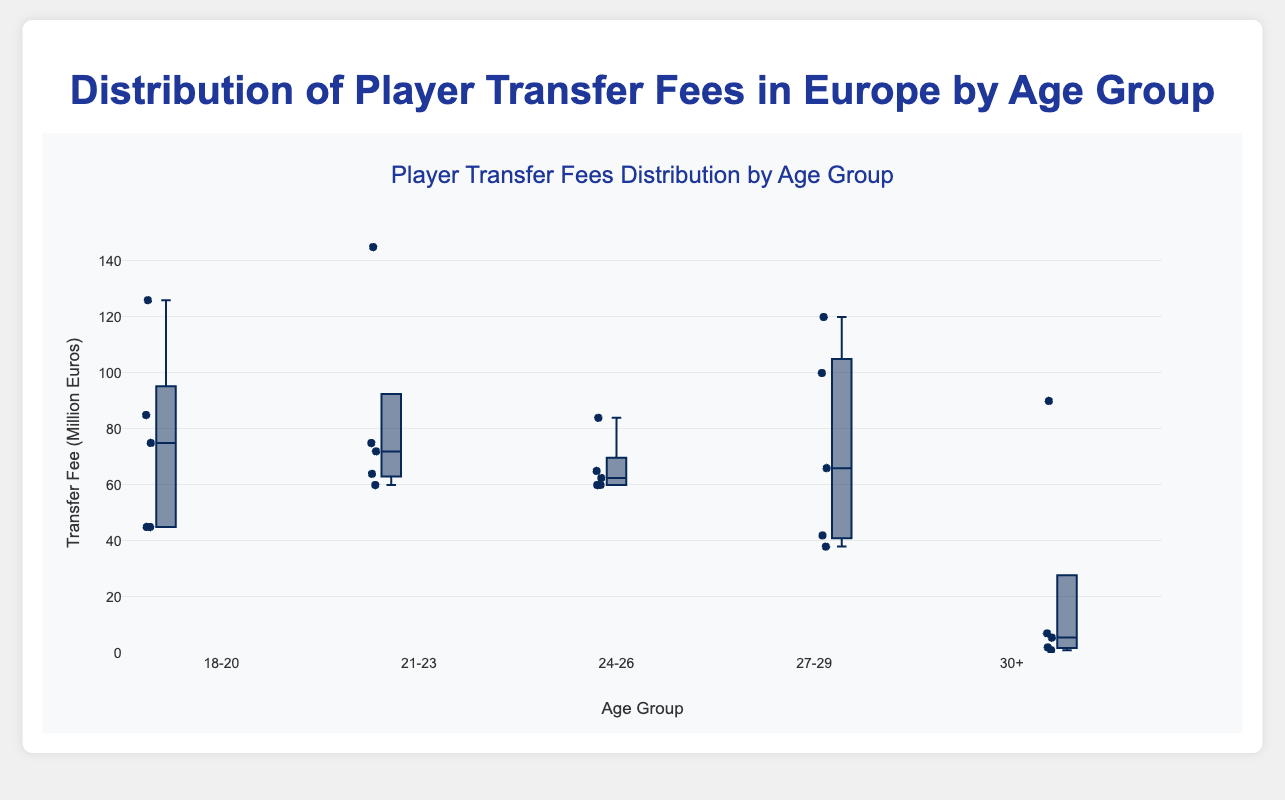Which age group has the highest median transfer fee? The median is typically visualized by the line inside the box of each box plot. By inspecting the line inside the box, we see that the 21-23 age group has the highest median transfer fee.
Answer: 21-23 What is the range of transfer fees for the 27-29 age group? The range is the difference between the maximum and minimum values. For the 27-29 age group, this range is depicted from the topmost to the bottommost point of the whiskers.
Answer: 120 - 38 = 82 million euros Which age group has the widest spread of transfer fees? The spread is indicated by the length of the box and whiskers. By comparing the lengths, the 30+ age group has the widest spread of transfer fees.
Answer: 30+ What is the interquartile range (IQR) for the 18-20 age group? The IQR is found by subtracting the value at the first quartile (Q1) from the value at the third quartile (Q3). For the 18-20 age group, Q1 is around 45 million euros and Q3 is around 85 million euros. IQR = Q3 - Q1.
Answer: 85 - 45 = 40 million euros Which player has the highest transfer fee in the 21-23 age group? Inspect the highest data point within the 21-23 age group box plot. The highest point is labeled with the player Kylian Mbappé, who has a fee of 145 million euros.
Answer: Kylian Mbappé How do the transfer fees for players aged 18-20 compare to those aged 30+? We need to compare both the median values and the spread of the data. From the box plots, the 18-20 age group has a higher median transfer fee and a more compact spread compared to the wider and lower spread of the 30+ age group.
Answer: 18-20 has higher median; 30+ has wider spread What is the approximate median transfer fee for the 24-26 age group? The median is represented by the line within the box. For the 24-26 age group, this line is at approximately 62.5 million euros.
Answer: 62.5 million euros Are there any outliers in the 18-20 age group based on the box plot? Outliers are typically shown as individual points beyond the whiskers. In the 18-20 age group, João Félix's transfer fee of 126 million euros is an outlier.
Answer: Yes, João Félix Which age group has the smallest range of transfer fees? The smallest range is indicated by the shortest distance between the topmost and bottommost points of the whiskers. The 24-26 age group has the smallest range.
Answer: 24-26 